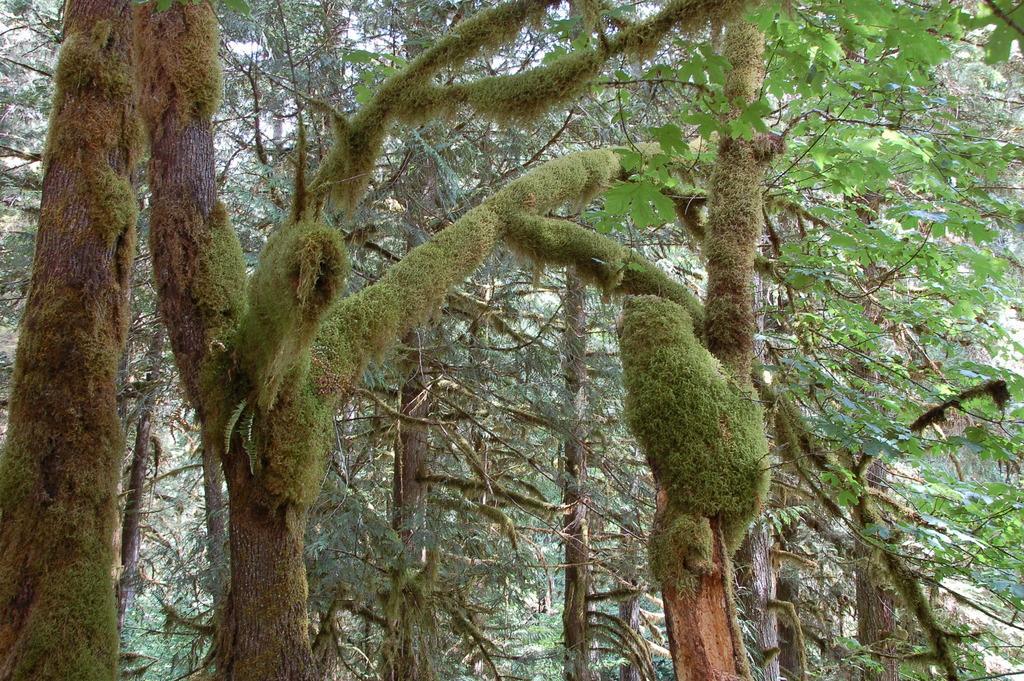Can you describe this image briefly? In this picture we can see many trees. On the right we can see green leaves. In the background we can see the mountain. 